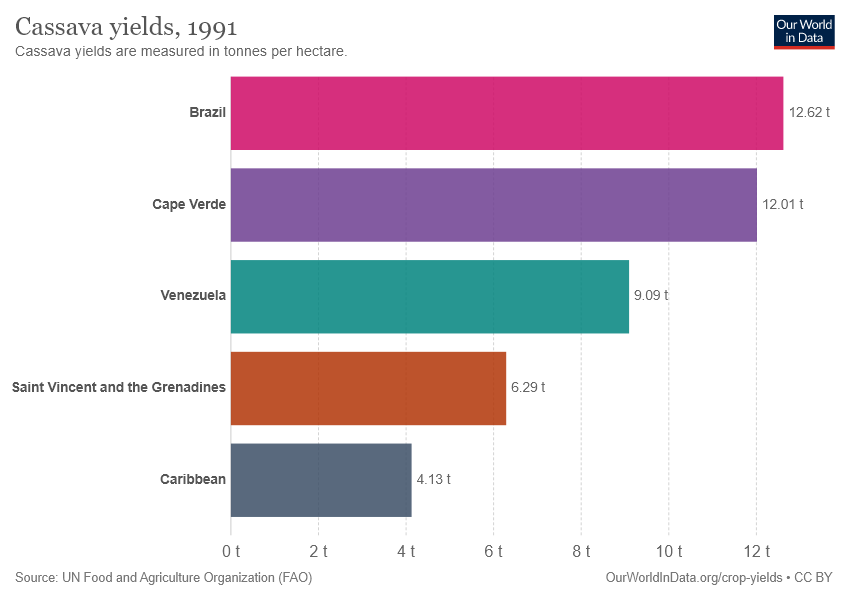Highlight a few significant elements in this photo. Brazil had a significantly higher cassava yield than the average yield of all the countries and regions considered. Specifically, the difference in cassava yield between Brazil and the average was 3.792. The yield of Cassava in Cape Verde is 12.01. 